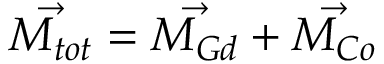<formula> <loc_0><loc_0><loc_500><loc_500>\vec { M _ { t o t } } = \vec { M _ { G d } } + \vec { M _ { C o } }</formula> 